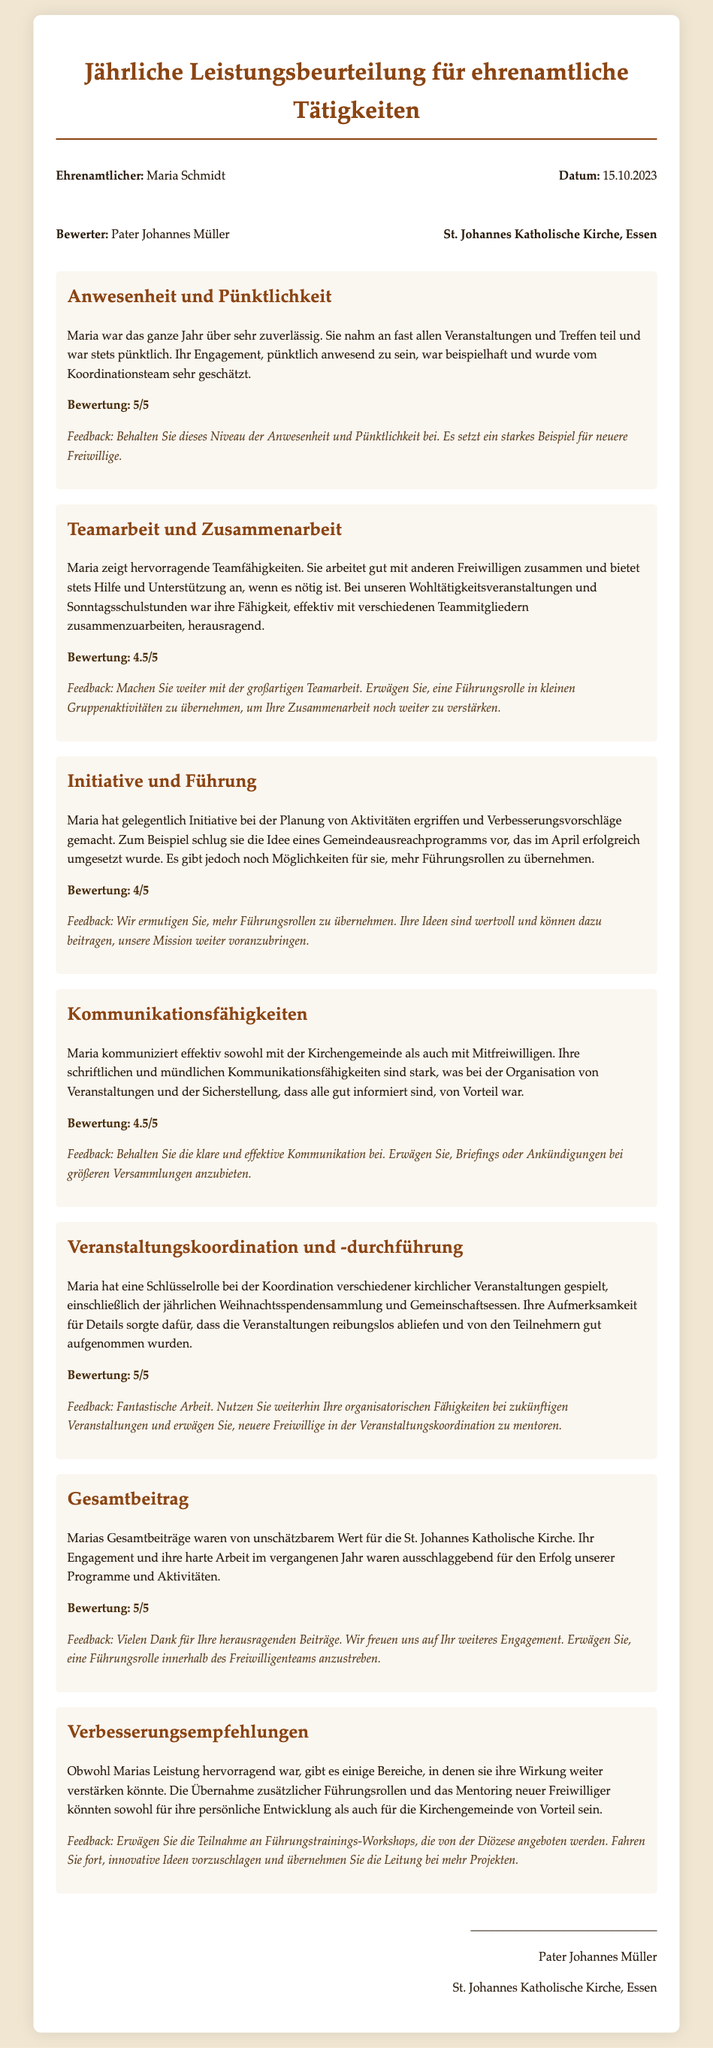What is the name of the volunteer? The document lists the volunteer's name at the top in the header section.
Answer: Maria Schmidt Who evaluated the performance? The evaluator's name is provided in the header section of the document.
Answer: Pater Johannes Müller What date was the evaluation conducted? The date of the evaluation is noted in the header section.
Answer: 15.10.2023 What was Maria's score for "Anwesenheit und Pünktlichkeit"? The score for this section is clearly mentioned within the section itself.
Answer: 5/5 What is one recommendation given to Maria regarding leadership? The document specifies recommendations in the last section about enhancing leadership skills.
Answer: Teilnahme an Führungstrainings-Workshops How was Maria's overall contribution described? The overall contribution summary includes qualitative evaluations.
Answer: Unspekztatbarem Wert What event did Maria help coordinate? The document mentions specific events where Maria played a key role in coordination.
Answer: Weihnachtsspendensammlung What feedback was provided for "Teamarbeit und Zusammenarbeit"? The feedback section includes insights on this aspect of her work.
Answer: Machen Sie weiter mit der großartigen Teamarbeit What is one area for improvement stated in the evaluation? The document includes a specific area of improvement towards the end.
Answer: Führungrollen übernehmen 